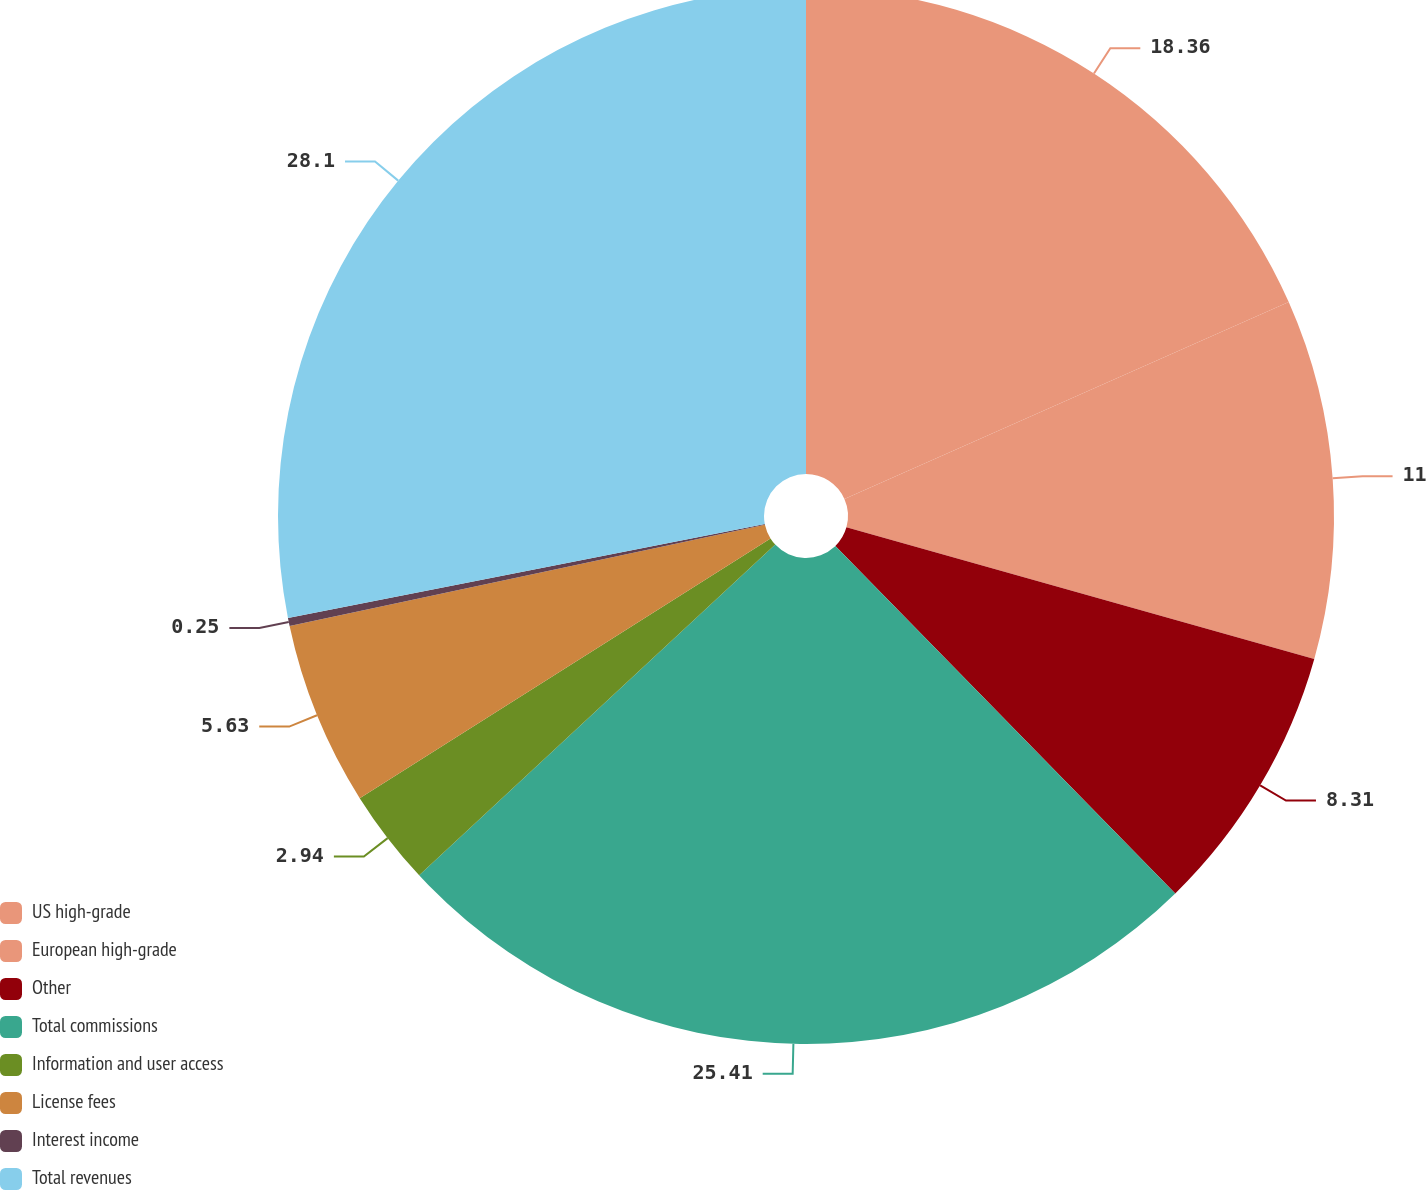Convert chart to OTSL. <chart><loc_0><loc_0><loc_500><loc_500><pie_chart><fcel>US high-grade<fcel>European high-grade<fcel>Other<fcel>Total commissions<fcel>Information and user access<fcel>License fees<fcel>Interest income<fcel>Total revenues<nl><fcel>18.36%<fcel>11.0%<fcel>8.31%<fcel>25.41%<fcel>2.94%<fcel>5.63%<fcel>0.25%<fcel>28.09%<nl></chart> 